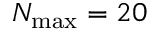Convert formula to latex. <formula><loc_0><loc_0><loc_500><loc_500>N _ { \max } = 2 0</formula> 